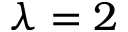Convert formula to latex. <formula><loc_0><loc_0><loc_500><loc_500>\lambda = 2</formula> 